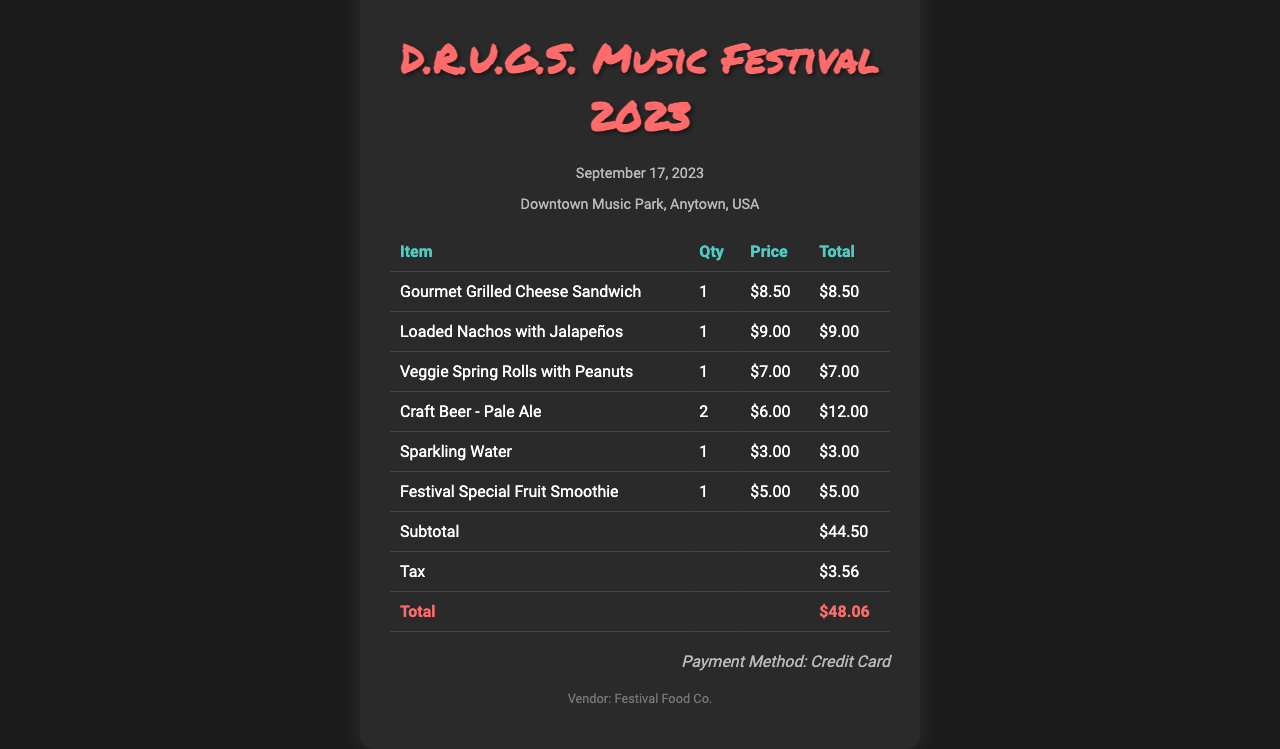What is the date of the festival? The date of the festival is specified in the document.
Answer: September 17, 2023 What is the name of the vendor? The vendor's name is mentioned in the document.
Answer: Festival Food Co How much did the Gourmet Grilled Cheese Sandwich cost? The price of the sandwich is listed under the itemized section.
Answer: $8.50 How many Craft Beer - Pale Ales were purchased? The quantity purchased is stated in the itemized list.
Answer: 2 What is the subtotal amount before tax? The subtotal is calculated before tax, as shown in the document.
Answer: $44.50 What was the total amount paid after tax? The total is calculated at the end of the receipt.
Answer: $48.06 What payment method was used? The payment method is specified in the payment information section.
Answer: Credit Card What type of drink is Sparkling Water categorized under? The type of drink can be inferred from its category in the receipt.
Answer: Beverage What items were included in the food section of the receipt? The food items can be seen specifically listed in the item table.
Answer: Gourmet Grilled Cheese Sandwich, Loaded Nachos with Jalapeños, Veggie Spring Rolls with Peanuts What was the price of the Tax? The tax amount is clearly detailed in the document.
Answer: $3.56 